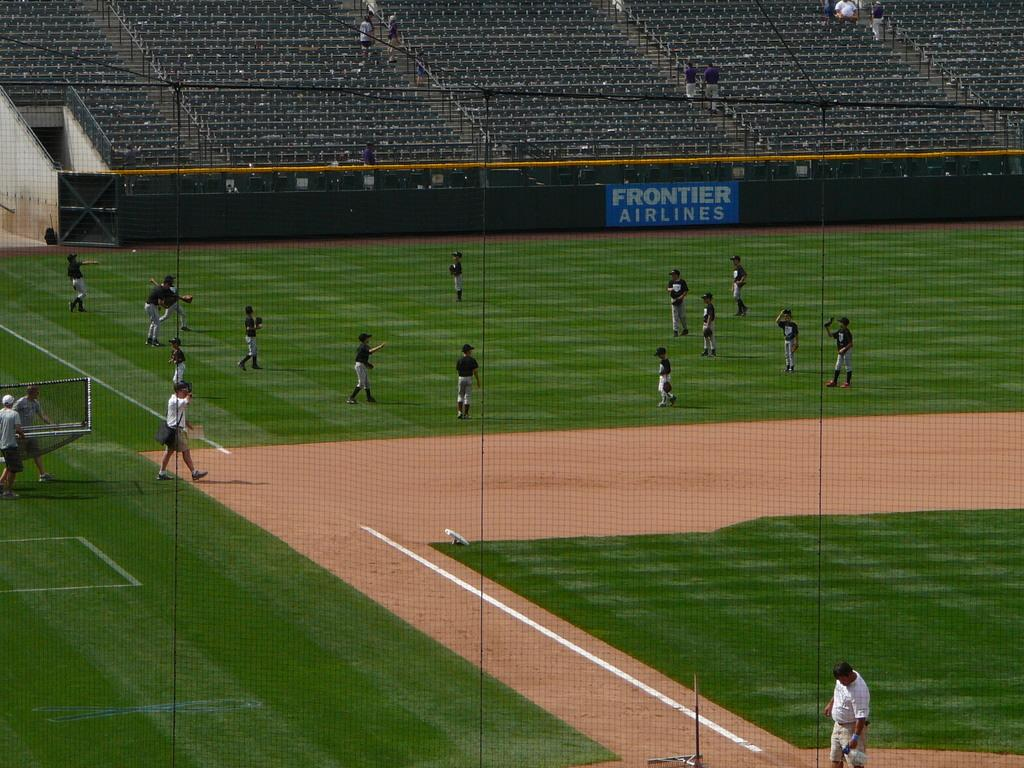Provide a one-sentence caption for the provided image. People playing baseball on a field with a blue sign that says "Frontier Airlines". 